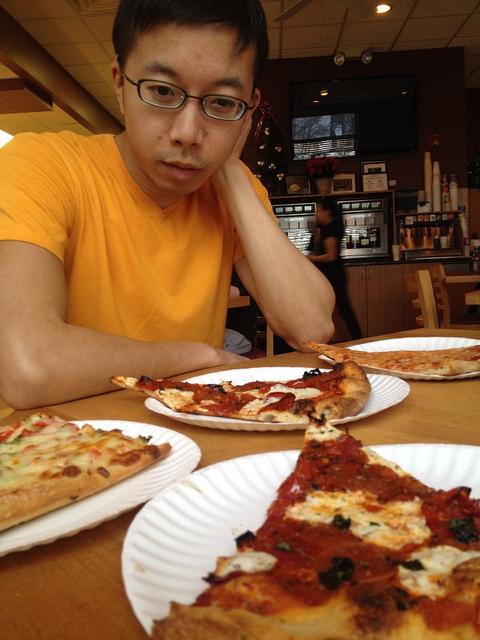Are there any salt and pepper shakers on the table?
Write a very short answer. No. What kind of plates are on the table?
Answer briefly. Paper. Does the child look happy or sad?
Answer briefly. Sad. What color is this guy's eyes?
Quick response, please. Brown. Is this pizza good?
Give a very brief answer. Yes. Is the photo outdoors?
Give a very brief answer. No. What are the toppings?
Answer briefly. Cheese and pepperoni. Are those plates made of glass?
Quick response, please. No. Is this food part of his culture?
Concise answer only. No. 